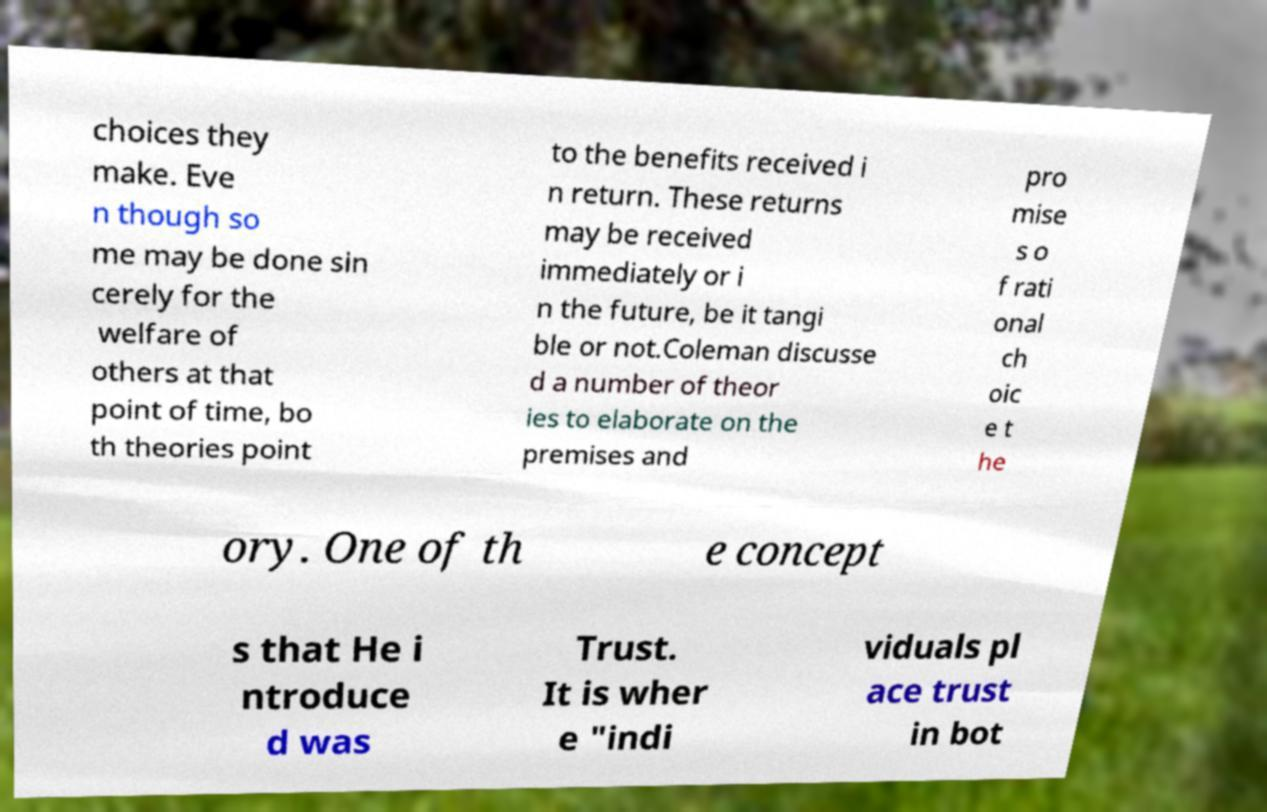For documentation purposes, I need the text within this image transcribed. Could you provide that? choices they make. Eve n though so me may be done sin cerely for the welfare of others at that point of time, bo th theories point to the benefits received i n return. These returns may be received immediately or i n the future, be it tangi ble or not.Coleman discusse d a number of theor ies to elaborate on the premises and pro mise s o f rati onal ch oic e t he ory. One of th e concept s that He i ntroduce d was Trust. It is wher e "indi viduals pl ace trust in bot 